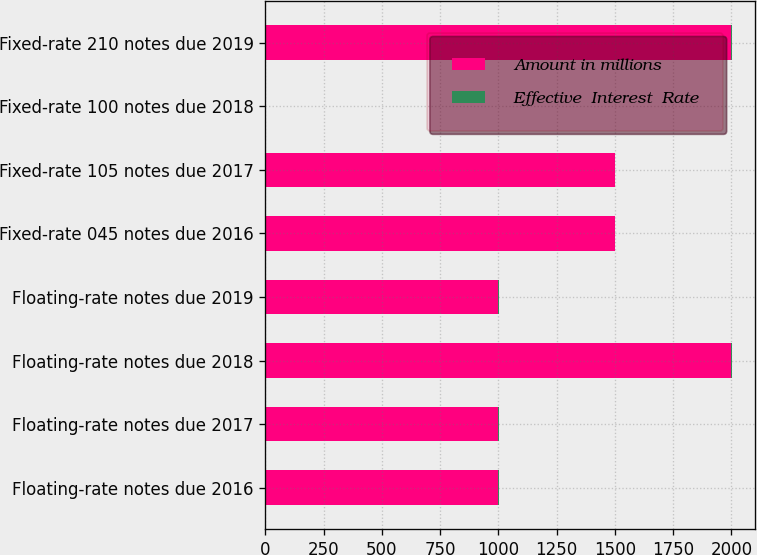Convert chart. <chart><loc_0><loc_0><loc_500><loc_500><stacked_bar_chart><ecel><fcel>Floating-rate notes due 2016<fcel>Floating-rate notes due 2017<fcel>Floating-rate notes due 2018<fcel>Floating-rate notes due 2019<fcel>Fixed-rate 045 notes due 2016<fcel>Fixed-rate 105 notes due 2017<fcel>Fixed-rate 100 notes due 2018<fcel>Fixed-rate 210 notes due 2019<nl><fcel>Amount in millions<fcel>1000<fcel>1000<fcel>2000<fcel>1000<fcel>1500<fcel>1500<fcel>1.1<fcel>2000<nl><fcel>Effective  Interest  Rate<fcel>0.51<fcel>0.31<fcel>1.1<fcel>0.54<fcel>0.51<fcel>0.3<fcel>1.08<fcel>0.53<nl></chart> 